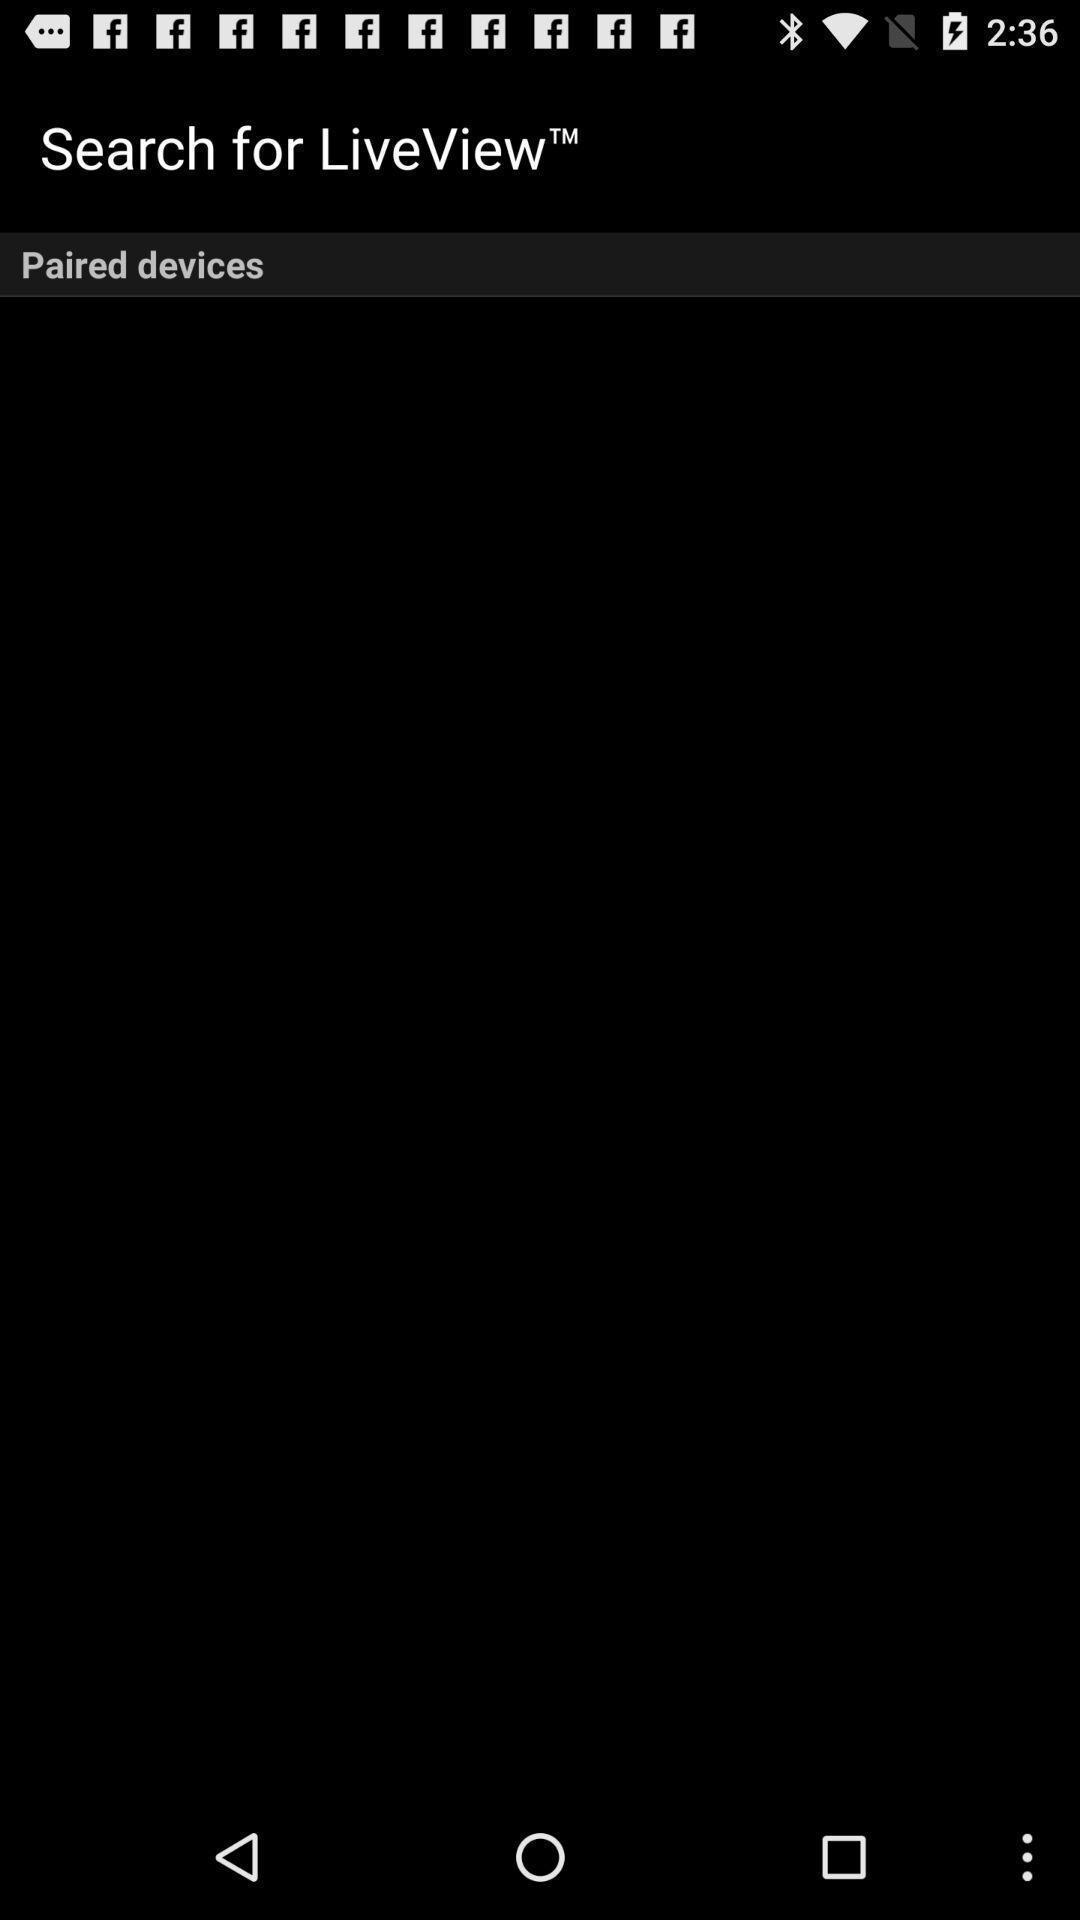Summarize the information in this screenshot. Screen shows paired devices page. 